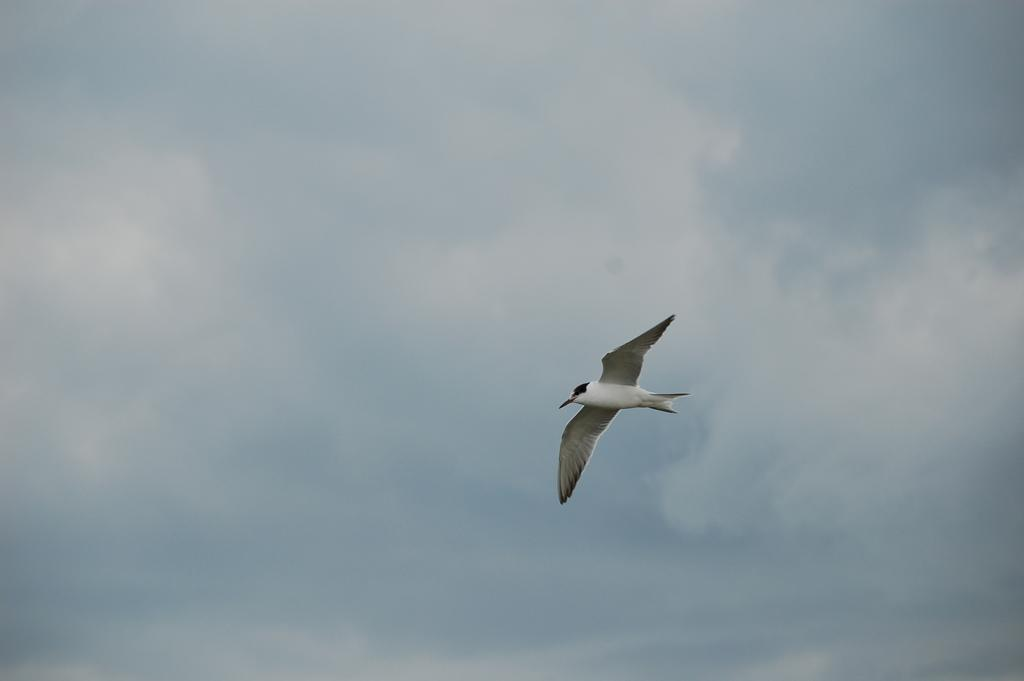What type of animal can be seen in the image? There is a bird in the image. What color is the bird? The bird is white in color. What else can be seen in the image besides the bird? The sky is visible in the image. Can you tell me where the bird's friend is located in the image? There is no information about a friend of the bird in the image, so it cannot be determined. 